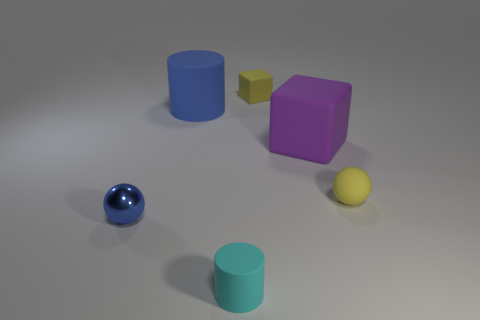There is a big cylinder that is the same material as the small yellow cube; what is its color?
Provide a succinct answer. Blue. What shape is the blue object that is in front of the big thing that is left of the rubber thing that is in front of the tiny blue thing?
Ensure brevity in your answer.  Sphere. What is the size of the purple thing?
Offer a terse response. Large. There is a purple object that is the same material as the tiny cyan object; what shape is it?
Ensure brevity in your answer.  Cube. Are there fewer purple matte things behind the metal ball than small matte cylinders?
Make the answer very short. No. What color is the ball left of the blue rubber thing?
Offer a terse response. Blue. There is a big object that is the same color as the small metallic object; what is its material?
Your answer should be compact. Rubber. Is there a small gray matte thing that has the same shape as the small cyan matte thing?
Make the answer very short. No. How many blue things are the same shape as the cyan thing?
Offer a terse response. 1. Do the tiny matte ball and the small cube have the same color?
Offer a terse response. Yes. 